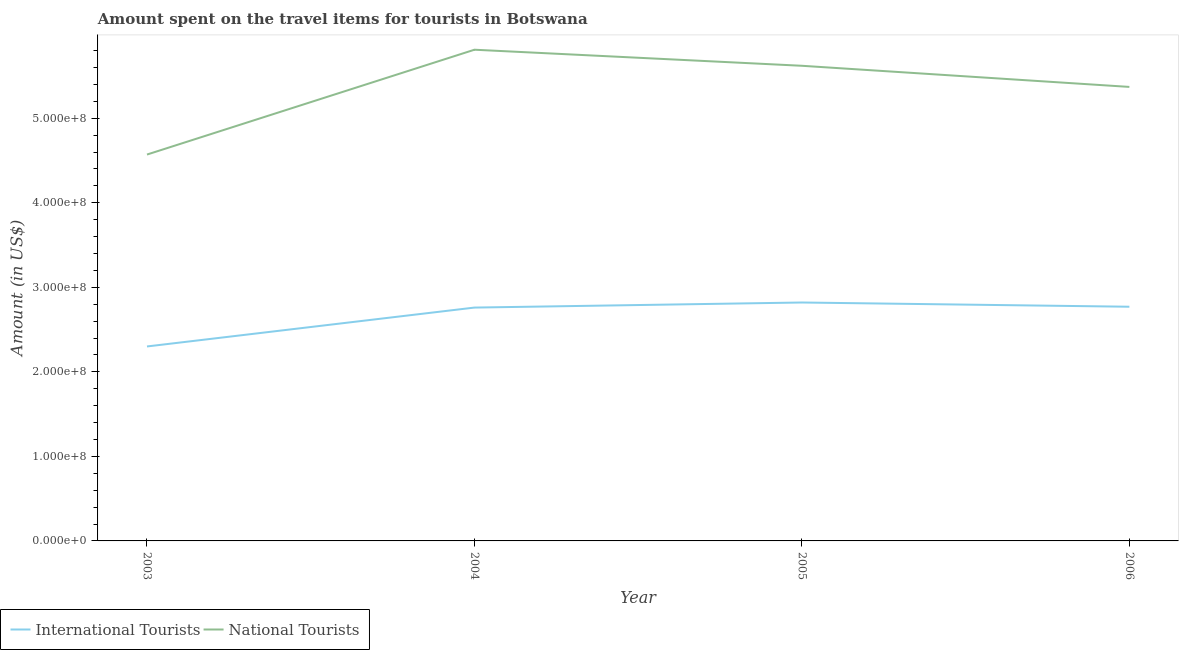Does the line corresponding to amount spent on travel items of international tourists intersect with the line corresponding to amount spent on travel items of national tourists?
Give a very brief answer. No. What is the amount spent on travel items of international tourists in 2005?
Ensure brevity in your answer.  2.82e+08. Across all years, what is the maximum amount spent on travel items of international tourists?
Your response must be concise. 2.82e+08. Across all years, what is the minimum amount spent on travel items of national tourists?
Ensure brevity in your answer.  4.57e+08. In which year was the amount spent on travel items of national tourists minimum?
Offer a very short reply. 2003. What is the total amount spent on travel items of national tourists in the graph?
Ensure brevity in your answer.  2.14e+09. What is the difference between the amount spent on travel items of national tourists in 2005 and that in 2006?
Your answer should be very brief. 2.50e+07. What is the difference between the amount spent on travel items of national tourists in 2003 and the amount spent on travel items of international tourists in 2004?
Your answer should be very brief. 1.81e+08. What is the average amount spent on travel items of international tourists per year?
Provide a short and direct response. 2.66e+08. In the year 2005, what is the difference between the amount spent on travel items of national tourists and amount spent on travel items of international tourists?
Your response must be concise. 2.80e+08. What is the ratio of the amount spent on travel items of national tourists in 2004 to that in 2006?
Offer a terse response. 1.08. Is the amount spent on travel items of national tourists in 2004 less than that in 2006?
Provide a succinct answer. No. Is the difference between the amount spent on travel items of international tourists in 2003 and 2005 greater than the difference between the amount spent on travel items of national tourists in 2003 and 2005?
Ensure brevity in your answer.  Yes. What is the difference between the highest and the lowest amount spent on travel items of international tourists?
Provide a short and direct response. 5.20e+07. In how many years, is the amount spent on travel items of international tourists greater than the average amount spent on travel items of international tourists taken over all years?
Provide a succinct answer. 3. Is the sum of the amount spent on travel items of national tourists in 2003 and 2006 greater than the maximum amount spent on travel items of international tourists across all years?
Your response must be concise. Yes. Does the amount spent on travel items of international tourists monotonically increase over the years?
Give a very brief answer. No. Is the amount spent on travel items of national tourists strictly greater than the amount spent on travel items of international tourists over the years?
Offer a terse response. Yes. How many years are there in the graph?
Make the answer very short. 4. Are the values on the major ticks of Y-axis written in scientific E-notation?
Offer a terse response. Yes. Does the graph contain any zero values?
Give a very brief answer. No. Where does the legend appear in the graph?
Provide a short and direct response. Bottom left. What is the title of the graph?
Keep it short and to the point. Amount spent on the travel items for tourists in Botswana. What is the label or title of the Y-axis?
Your answer should be compact. Amount (in US$). What is the Amount (in US$) of International Tourists in 2003?
Your response must be concise. 2.30e+08. What is the Amount (in US$) in National Tourists in 2003?
Make the answer very short. 4.57e+08. What is the Amount (in US$) in International Tourists in 2004?
Keep it short and to the point. 2.76e+08. What is the Amount (in US$) in National Tourists in 2004?
Your answer should be very brief. 5.81e+08. What is the Amount (in US$) of International Tourists in 2005?
Give a very brief answer. 2.82e+08. What is the Amount (in US$) of National Tourists in 2005?
Your response must be concise. 5.62e+08. What is the Amount (in US$) of International Tourists in 2006?
Your response must be concise. 2.77e+08. What is the Amount (in US$) of National Tourists in 2006?
Offer a terse response. 5.37e+08. Across all years, what is the maximum Amount (in US$) in International Tourists?
Ensure brevity in your answer.  2.82e+08. Across all years, what is the maximum Amount (in US$) in National Tourists?
Your answer should be very brief. 5.81e+08. Across all years, what is the minimum Amount (in US$) in International Tourists?
Provide a succinct answer. 2.30e+08. Across all years, what is the minimum Amount (in US$) of National Tourists?
Offer a very short reply. 4.57e+08. What is the total Amount (in US$) in International Tourists in the graph?
Provide a succinct answer. 1.06e+09. What is the total Amount (in US$) of National Tourists in the graph?
Offer a terse response. 2.14e+09. What is the difference between the Amount (in US$) of International Tourists in 2003 and that in 2004?
Make the answer very short. -4.60e+07. What is the difference between the Amount (in US$) in National Tourists in 2003 and that in 2004?
Your answer should be very brief. -1.24e+08. What is the difference between the Amount (in US$) of International Tourists in 2003 and that in 2005?
Keep it short and to the point. -5.20e+07. What is the difference between the Amount (in US$) of National Tourists in 2003 and that in 2005?
Make the answer very short. -1.05e+08. What is the difference between the Amount (in US$) in International Tourists in 2003 and that in 2006?
Give a very brief answer. -4.70e+07. What is the difference between the Amount (in US$) of National Tourists in 2003 and that in 2006?
Provide a short and direct response. -8.00e+07. What is the difference between the Amount (in US$) of International Tourists in 2004 and that in 2005?
Your response must be concise. -6.00e+06. What is the difference between the Amount (in US$) in National Tourists in 2004 and that in 2005?
Your answer should be compact. 1.90e+07. What is the difference between the Amount (in US$) in National Tourists in 2004 and that in 2006?
Your answer should be very brief. 4.40e+07. What is the difference between the Amount (in US$) of National Tourists in 2005 and that in 2006?
Give a very brief answer. 2.50e+07. What is the difference between the Amount (in US$) of International Tourists in 2003 and the Amount (in US$) of National Tourists in 2004?
Your response must be concise. -3.51e+08. What is the difference between the Amount (in US$) in International Tourists in 2003 and the Amount (in US$) in National Tourists in 2005?
Provide a succinct answer. -3.32e+08. What is the difference between the Amount (in US$) in International Tourists in 2003 and the Amount (in US$) in National Tourists in 2006?
Offer a terse response. -3.07e+08. What is the difference between the Amount (in US$) in International Tourists in 2004 and the Amount (in US$) in National Tourists in 2005?
Your response must be concise. -2.86e+08. What is the difference between the Amount (in US$) of International Tourists in 2004 and the Amount (in US$) of National Tourists in 2006?
Keep it short and to the point. -2.61e+08. What is the difference between the Amount (in US$) of International Tourists in 2005 and the Amount (in US$) of National Tourists in 2006?
Offer a terse response. -2.55e+08. What is the average Amount (in US$) of International Tourists per year?
Offer a terse response. 2.66e+08. What is the average Amount (in US$) in National Tourists per year?
Make the answer very short. 5.34e+08. In the year 2003, what is the difference between the Amount (in US$) in International Tourists and Amount (in US$) in National Tourists?
Keep it short and to the point. -2.27e+08. In the year 2004, what is the difference between the Amount (in US$) of International Tourists and Amount (in US$) of National Tourists?
Keep it short and to the point. -3.05e+08. In the year 2005, what is the difference between the Amount (in US$) in International Tourists and Amount (in US$) in National Tourists?
Make the answer very short. -2.80e+08. In the year 2006, what is the difference between the Amount (in US$) in International Tourists and Amount (in US$) in National Tourists?
Make the answer very short. -2.60e+08. What is the ratio of the Amount (in US$) in National Tourists in 2003 to that in 2004?
Offer a very short reply. 0.79. What is the ratio of the Amount (in US$) in International Tourists in 2003 to that in 2005?
Your answer should be very brief. 0.82. What is the ratio of the Amount (in US$) of National Tourists in 2003 to that in 2005?
Provide a short and direct response. 0.81. What is the ratio of the Amount (in US$) of International Tourists in 2003 to that in 2006?
Your answer should be compact. 0.83. What is the ratio of the Amount (in US$) in National Tourists in 2003 to that in 2006?
Keep it short and to the point. 0.85. What is the ratio of the Amount (in US$) in International Tourists in 2004 to that in 2005?
Give a very brief answer. 0.98. What is the ratio of the Amount (in US$) of National Tourists in 2004 to that in 2005?
Give a very brief answer. 1.03. What is the ratio of the Amount (in US$) in International Tourists in 2004 to that in 2006?
Provide a succinct answer. 1. What is the ratio of the Amount (in US$) in National Tourists in 2004 to that in 2006?
Offer a terse response. 1.08. What is the ratio of the Amount (in US$) of International Tourists in 2005 to that in 2006?
Offer a terse response. 1.02. What is the ratio of the Amount (in US$) of National Tourists in 2005 to that in 2006?
Ensure brevity in your answer.  1.05. What is the difference between the highest and the second highest Amount (in US$) in National Tourists?
Offer a terse response. 1.90e+07. What is the difference between the highest and the lowest Amount (in US$) of International Tourists?
Give a very brief answer. 5.20e+07. What is the difference between the highest and the lowest Amount (in US$) of National Tourists?
Your answer should be very brief. 1.24e+08. 